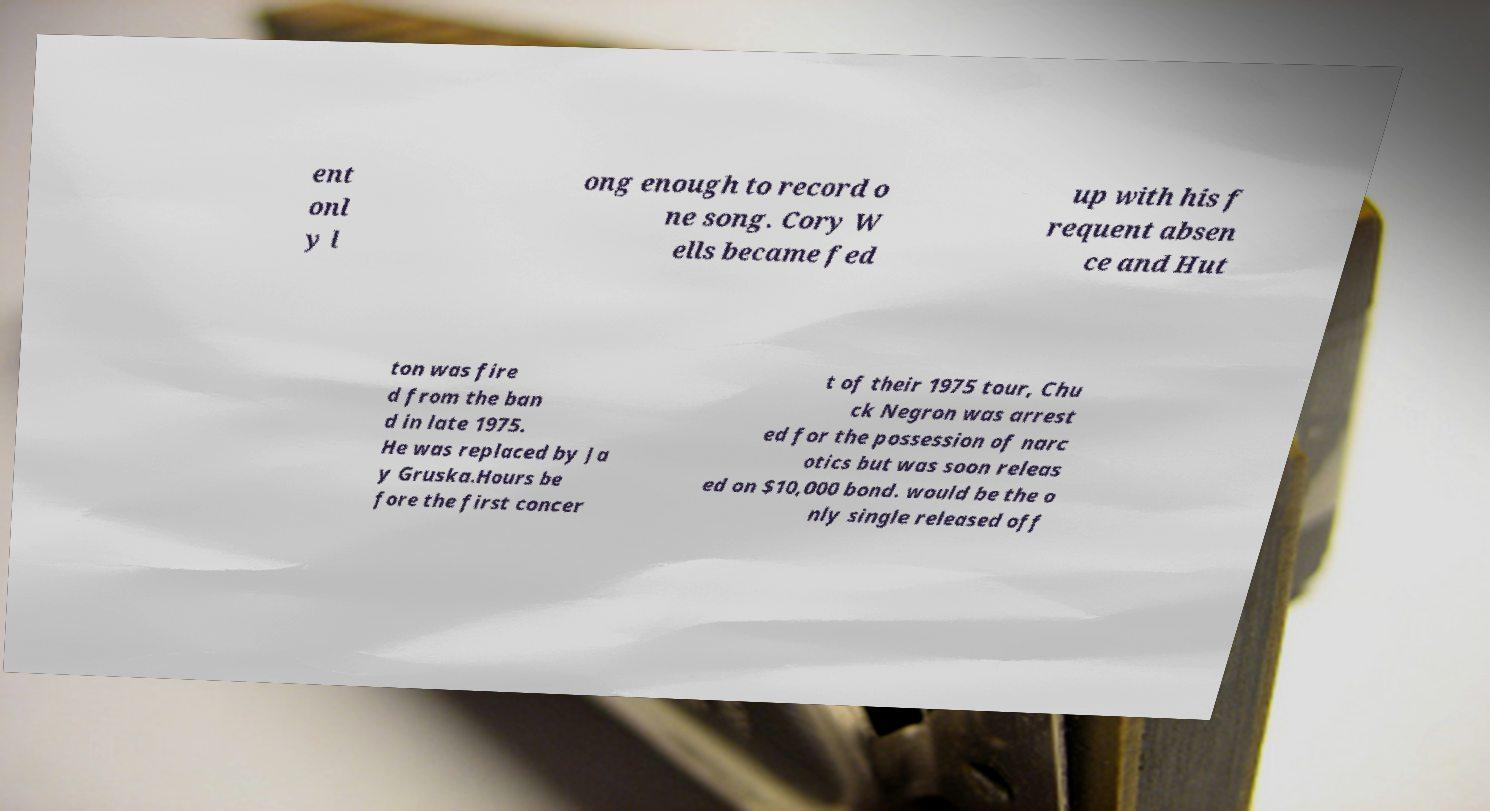I need the written content from this picture converted into text. Can you do that? ent onl y l ong enough to record o ne song. Cory W ells became fed up with his f requent absen ce and Hut ton was fire d from the ban d in late 1975. He was replaced by Ja y Gruska.Hours be fore the first concer t of their 1975 tour, Chu ck Negron was arrest ed for the possession of narc otics but was soon releas ed on $10,000 bond. would be the o nly single released off 